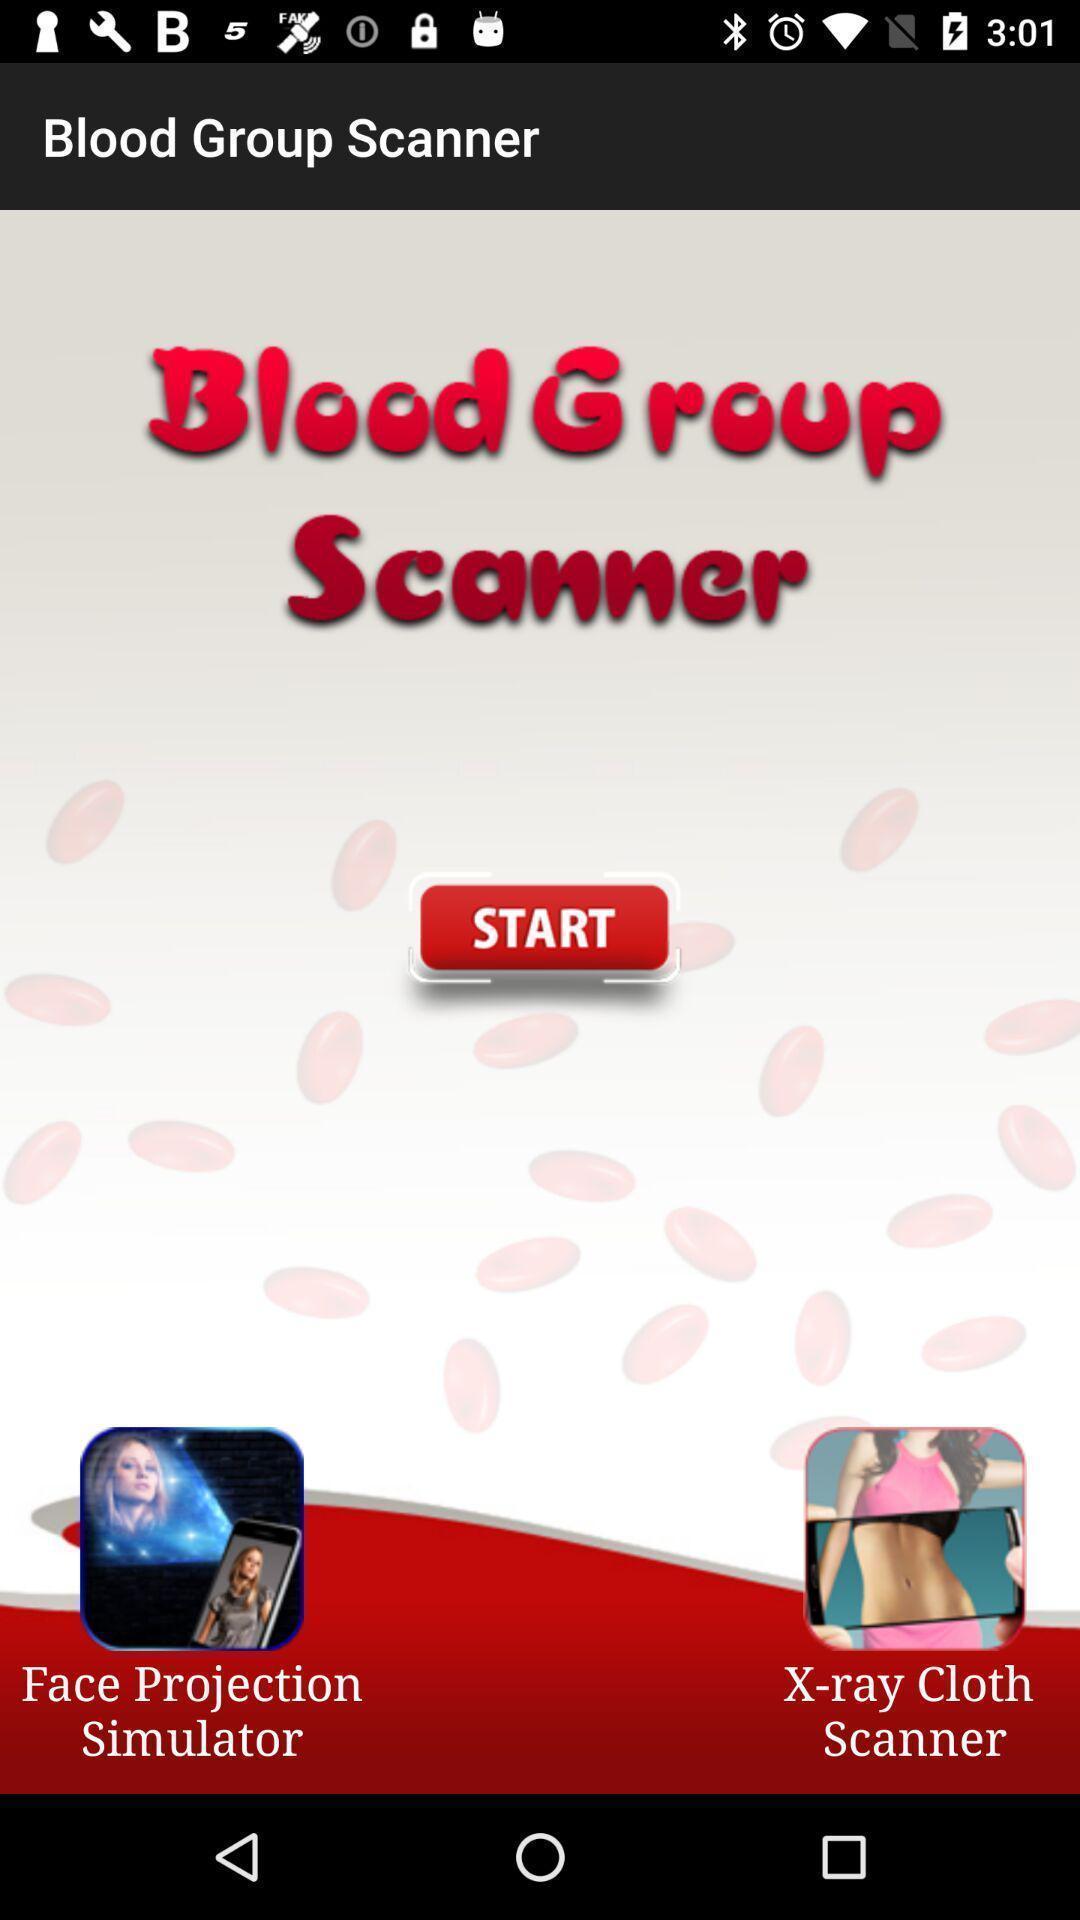Provide a detailed account of this screenshot. Welcome page of a scanner app. 